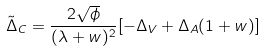<formula> <loc_0><loc_0><loc_500><loc_500>\tilde { \Delta } _ { C } = \frac { 2 \sqrt { \phi } } { ( \lambda + w ) ^ { 2 } } [ - \Delta _ { V } + \Delta _ { A } ( 1 + w ) ]</formula> 